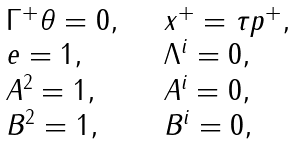Convert formula to latex. <formula><loc_0><loc_0><loc_500><loc_500>\begin{array} { l l } \Gamma ^ { + } \theta = 0 , \quad & x ^ { + } = \tau p ^ { + } , \\ e = 1 , \quad & \Lambda ^ { i } = 0 , \\ A ^ { 2 } = 1 , \quad & A ^ { i } = 0 , \\ B ^ { 2 } = 1 , \quad & B ^ { i } = 0 , \\ \end{array}</formula> 